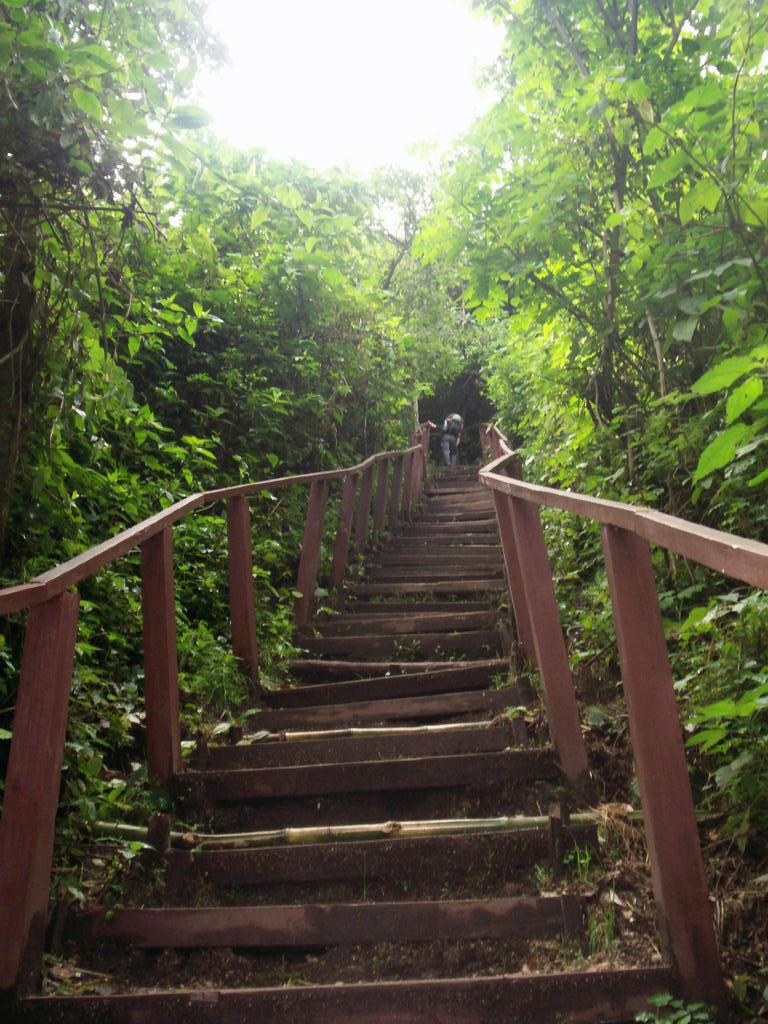What type of structure is visible in the image? There are stairs in the image. Is there anyone using the stairs in the image? Yes, a person is present on the stairs. What can be seen on both sides of the image? There are trees on both sides of the image. What is visible in the background of the image? The sky is visible in the background of the image. What type of memory is being stored in the image? There is no reference to memory storage in the image; it features stairs, a person, trees, and the sky. What type of building is visible in the image? There is no building visible in the image; it features stairs, a person, trees, and the sky. 